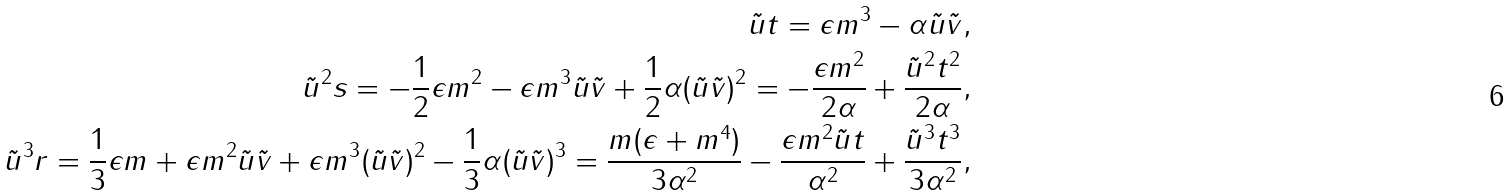<formula> <loc_0><loc_0><loc_500><loc_500>\tilde { u } t = \epsilon m ^ { 3 } - \alpha \tilde { u } \tilde { v } , \\ \tilde { u } ^ { 2 } s = - \frac { 1 } { 2 } \epsilon m ^ { 2 } - \epsilon m ^ { 3 } \tilde { u } \tilde { v } + \frac { 1 } { 2 } \alpha ( \tilde { u } \tilde { v } ) ^ { 2 } = - \frac { \epsilon m ^ { 2 } } { 2 \alpha } + \frac { \tilde { u } ^ { 2 } t ^ { 2 } } { 2 \alpha } , \\ \tilde { u } ^ { 3 } r = \frac { 1 } { 3 } \epsilon m + \epsilon m ^ { 2 } \tilde { u } \tilde { v } + \epsilon m ^ { 3 } ( \tilde { u } \tilde { v } ) ^ { 2 } - \frac { 1 } { 3 } \alpha ( \tilde { u } \tilde { v } ) ^ { 3 } = \frac { m ( \epsilon + m ^ { 4 } ) } { 3 \alpha ^ { 2 } } - \frac { \epsilon m ^ { 2 } \tilde { u } t } { \alpha ^ { 2 } } + \frac { \tilde { u } ^ { 3 } t ^ { 3 } } { 3 \alpha ^ { 2 } } ,</formula> 